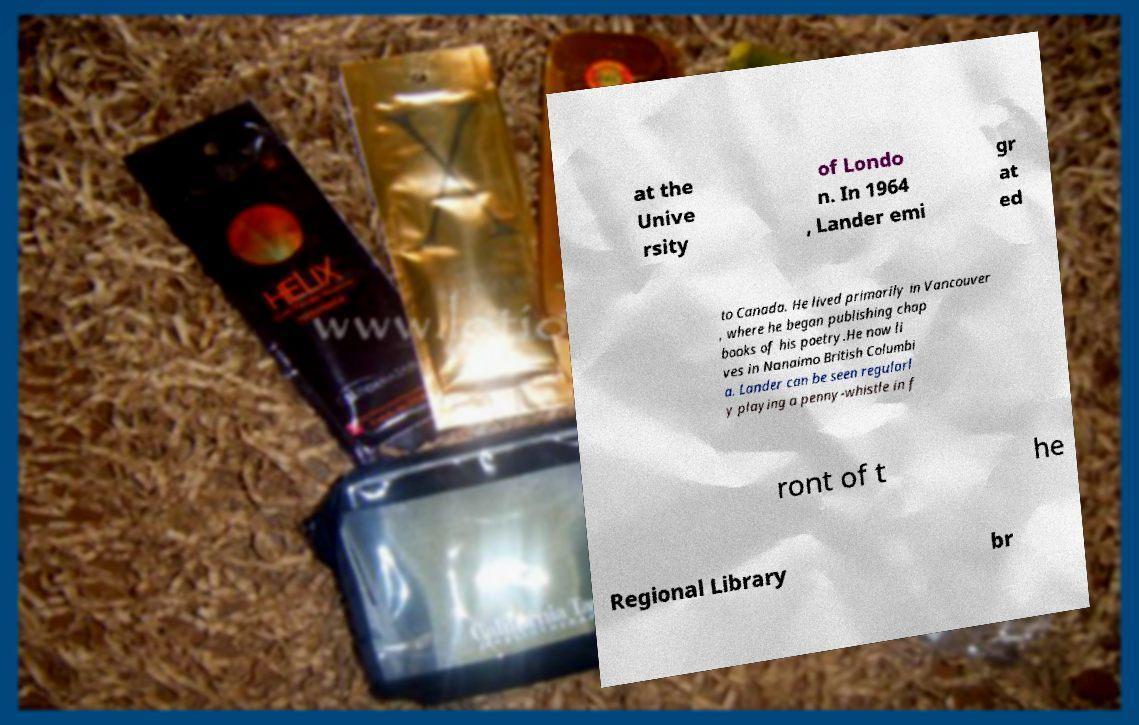For documentation purposes, I need the text within this image transcribed. Could you provide that? at the Unive rsity of Londo n. In 1964 , Lander emi gr at ed to Canada. He lived primarily in Vancouver , where he began publishing chap books of his poetry.He now li ves in Nanaimo British Columbi a. Lander can be seen regularl y playing a penny-whistle in f ront of t he Regional Library br 